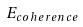<formula> <loc_0><loc_0><loc_500><loc_500>E _ { c o h e r e n c e }</formula> 